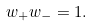<formula> <loc_0><loc_0><loc_500><loc_500>w _ { + } w _ { - } = 1 .</formula> 